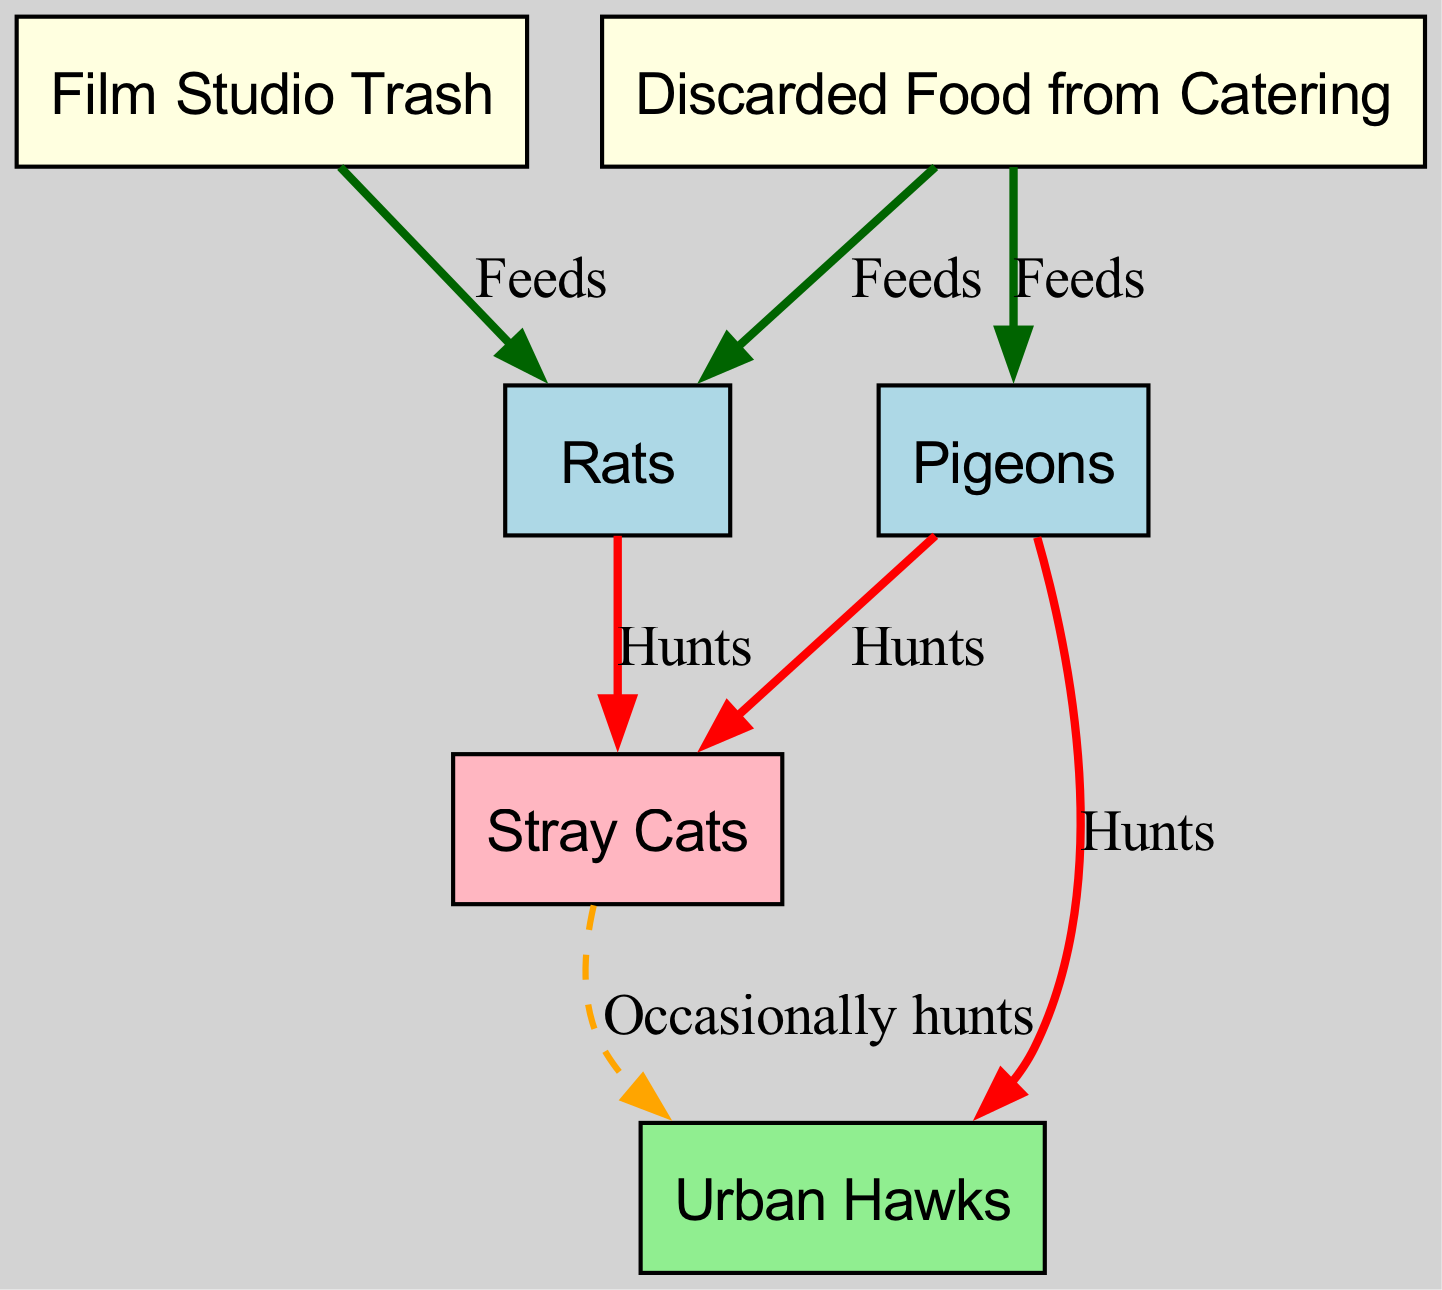What are the nodes in the food chain? The nodes in the food chain represent different entities in the urban ecosystem, including "Film Studio Trash," "Discarded Food from Catering," "Pigeons," "Rats," "Stray Cats," and "Urban Hawks." Each node represents a different contributor or participant in the food chain.
Answer: Film Studio Trash, Discarded Food from Catering, Pigeons, Rats, Stray Cats, Urban Hawks How many edges are there in the food chain? The edges in the diagram represent the relationships between the nodes. By counting the connections listed in the edges section, there are a total of 7 edges linking the nodes.
Answer: 7 What feeds on pigeons? According to the diagram, "Stray Cats" and "Urban Hawks" both hunt pigeons, indicating that they prey on them as part of the food chain.
Answer: Stray Cats, Urban Hawks What is the relationship between "Film Studio Trash" and "Rats"? The diagram shows that "Film Studio Trash" feeds "Rats," meaning that the trash provides a food source for the rat population.
Answer: Feeds Which animal is at the top of the food chain in this urban ecosystem? The diagram indicates that "Urban Hawks" are at the top of the food chain, as they are the predators that hunt other animals such as pigeons and stray cats.
Answer: Urban Hawks How do "Stray Cats" relate to "Urban Hawks"? The diagram indicates that "Stray Cats" are occasionally hunted by "Urban Hawks," illustrating a predatory relationship in the food chain.
Answer: Occasionally hunts What do rats feed on in this ecosystem? In the urban ecosystem represented in this diagram, rats feed on "Film Studio Trash" and "Discarded Food from Catering," showing their dependence on waste and leftovers for survival.
Answer: Film Studio Trash, Discarded Food from Catering Which animals are hunted by stray cats? The stray cats hunt both "Pigeons" and "Rats," as indicated by the directed edges in the food chain diagram, which showcases their role as predators in the ecosystem.
Answer: Pigeons, Rats 